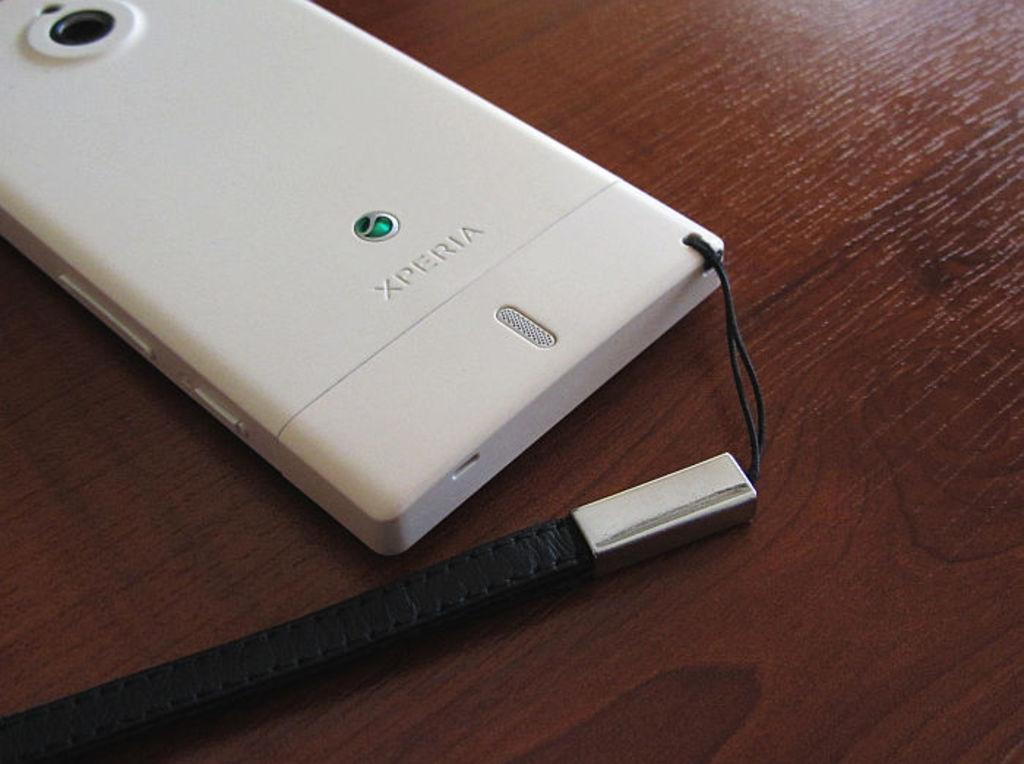<image>
Provide a brief description of the given image. The back of a white phone shows that it is from Xperia. 